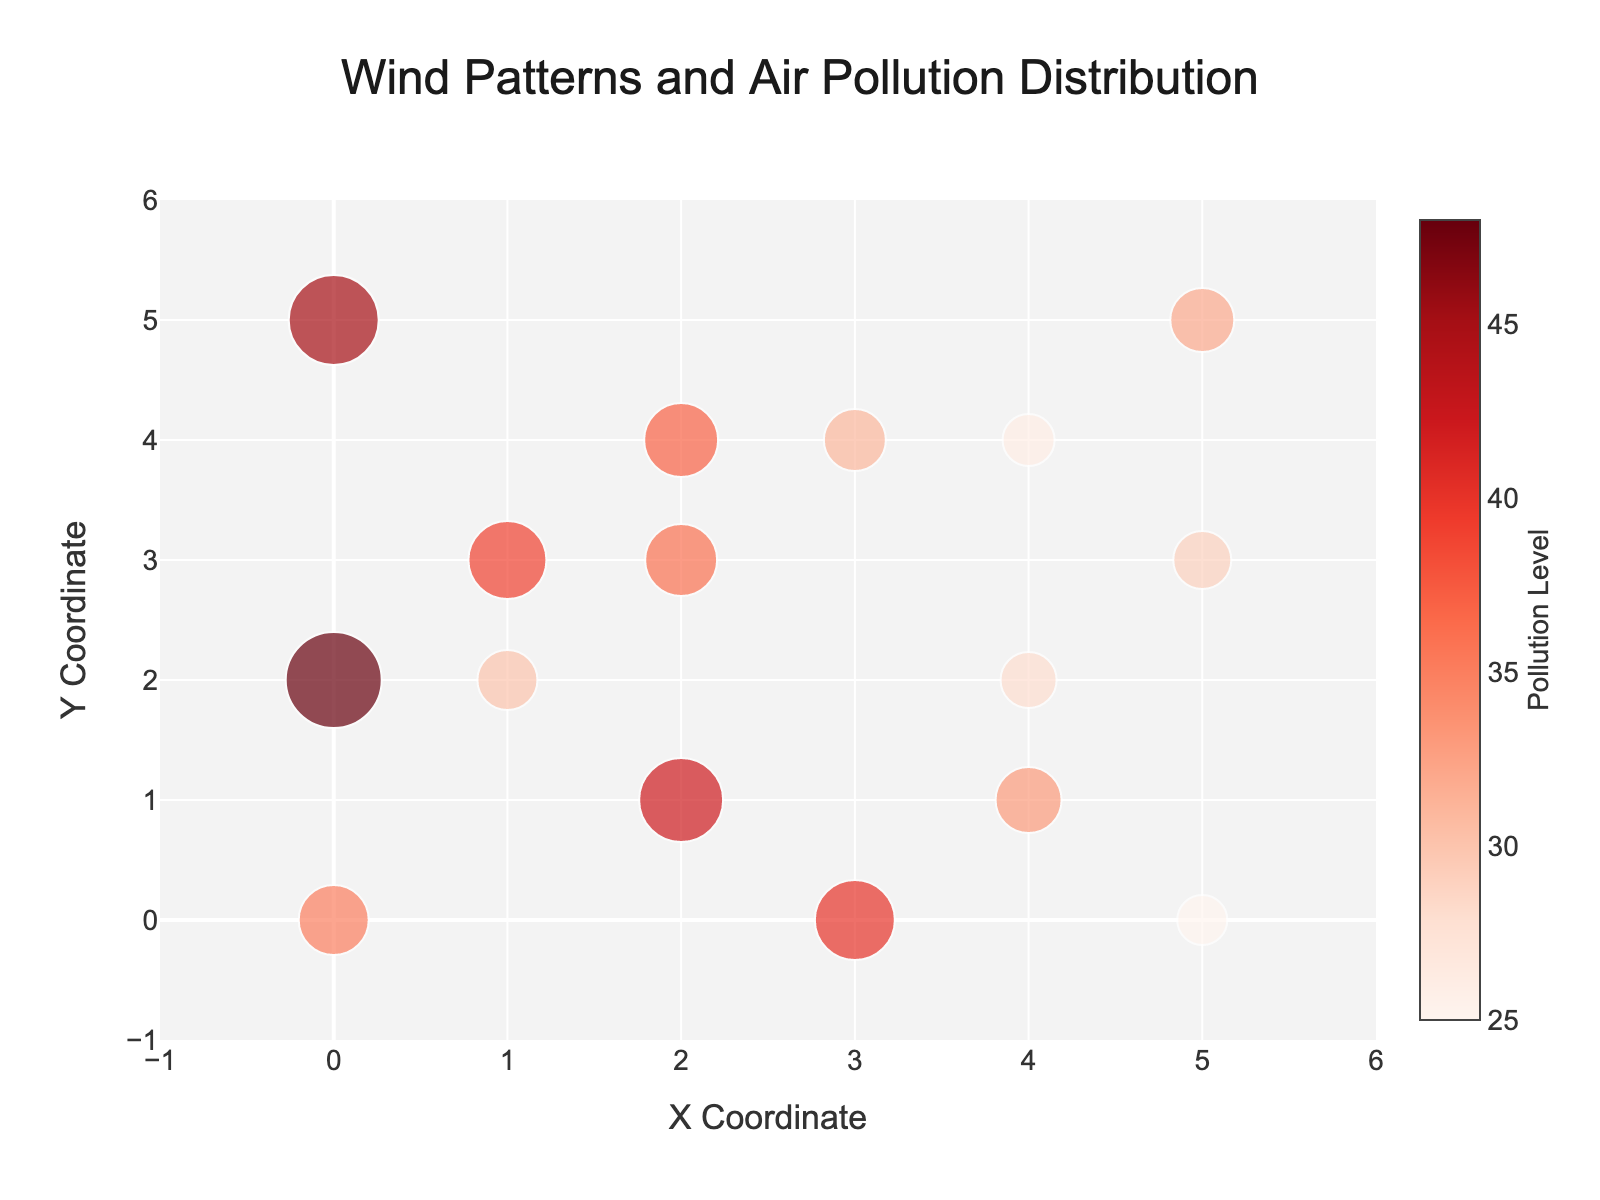what is the range of the x-axis? The x-axis range is shown on the figure, extending from -1 to 6.
Answer: -1 to 6 Which point has the highest level of air pollution? From the color scale, the point with the highest pollution level is identified by the darkest red color. Looking at the points, the coordinates (0, 2) have the highest pollution level of 48.
Answer: (0, 2) How do the wind patterns around points with high pollution levels compare to those with low pollution levels? Observing the directional arrows (cones) around the pollution levels, it can be noted that areas with high pollution (darker reds) often have wind vectors that are not very strong and sometimes directed inward, whereas areas with lower pollution (lighter reds) have more outward or stronger wind patterns.
Answer: Varies by strength and direction What's the pollution level at the point (2, 1)? Locate the point (2, 1) in the figure and note its pollution level from the color intensity and the marker size. It is 42.
Answer: 42 Compare the wind patterns at (5, 0) and (3, 0). Which is stronger? By comparing the length of the cones (wind vectors) at these coordinates, the cone at (5, 0) is longer than the one at (3, 0), indicating stronger wind at (5, 0).
Answer: (5, 0) Which point has the lowest level of air pollution? The point with the lightest red color corresponds to the lowest level of pollution. It occurs at the point (5, 0) with a pollution level of 25.
Answer: (5, 0) How many points have pollution levels greater than 40? Count the number of points that have a color intensity corresponding to pollution levels above 40. These points are at (2, 1) with 42, and (0, 2) with 48, and (0, 5) with 45.
Answer: 3 What's the direction of the wind at point (1, 3)? Observing the cone’s direction at (1, 3), the wind vector points upward and to the right.
Answer: Upward and to the right Which coordinate has wind directed to the Southeast? Southeast direction means the wind vector points down and to the right. The point (5, 3) has this orientation.
Answer: (5, 3) Summarize how wind direction influences pollution levels in this figure. By observing wind patterns and pollution levels, regions where wind vectors are weak or converge tend to have higher pollution, whereas strong or diverging winds often correlate with lower pollution levels.
Answer: Wind strength and direction influence pollution scatter 